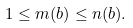Convert formula to latex. <formula><loc_0><loc_0><loc_500><loc_500>1 \leq m ( b ) \leq n ( b ) .</formula> 